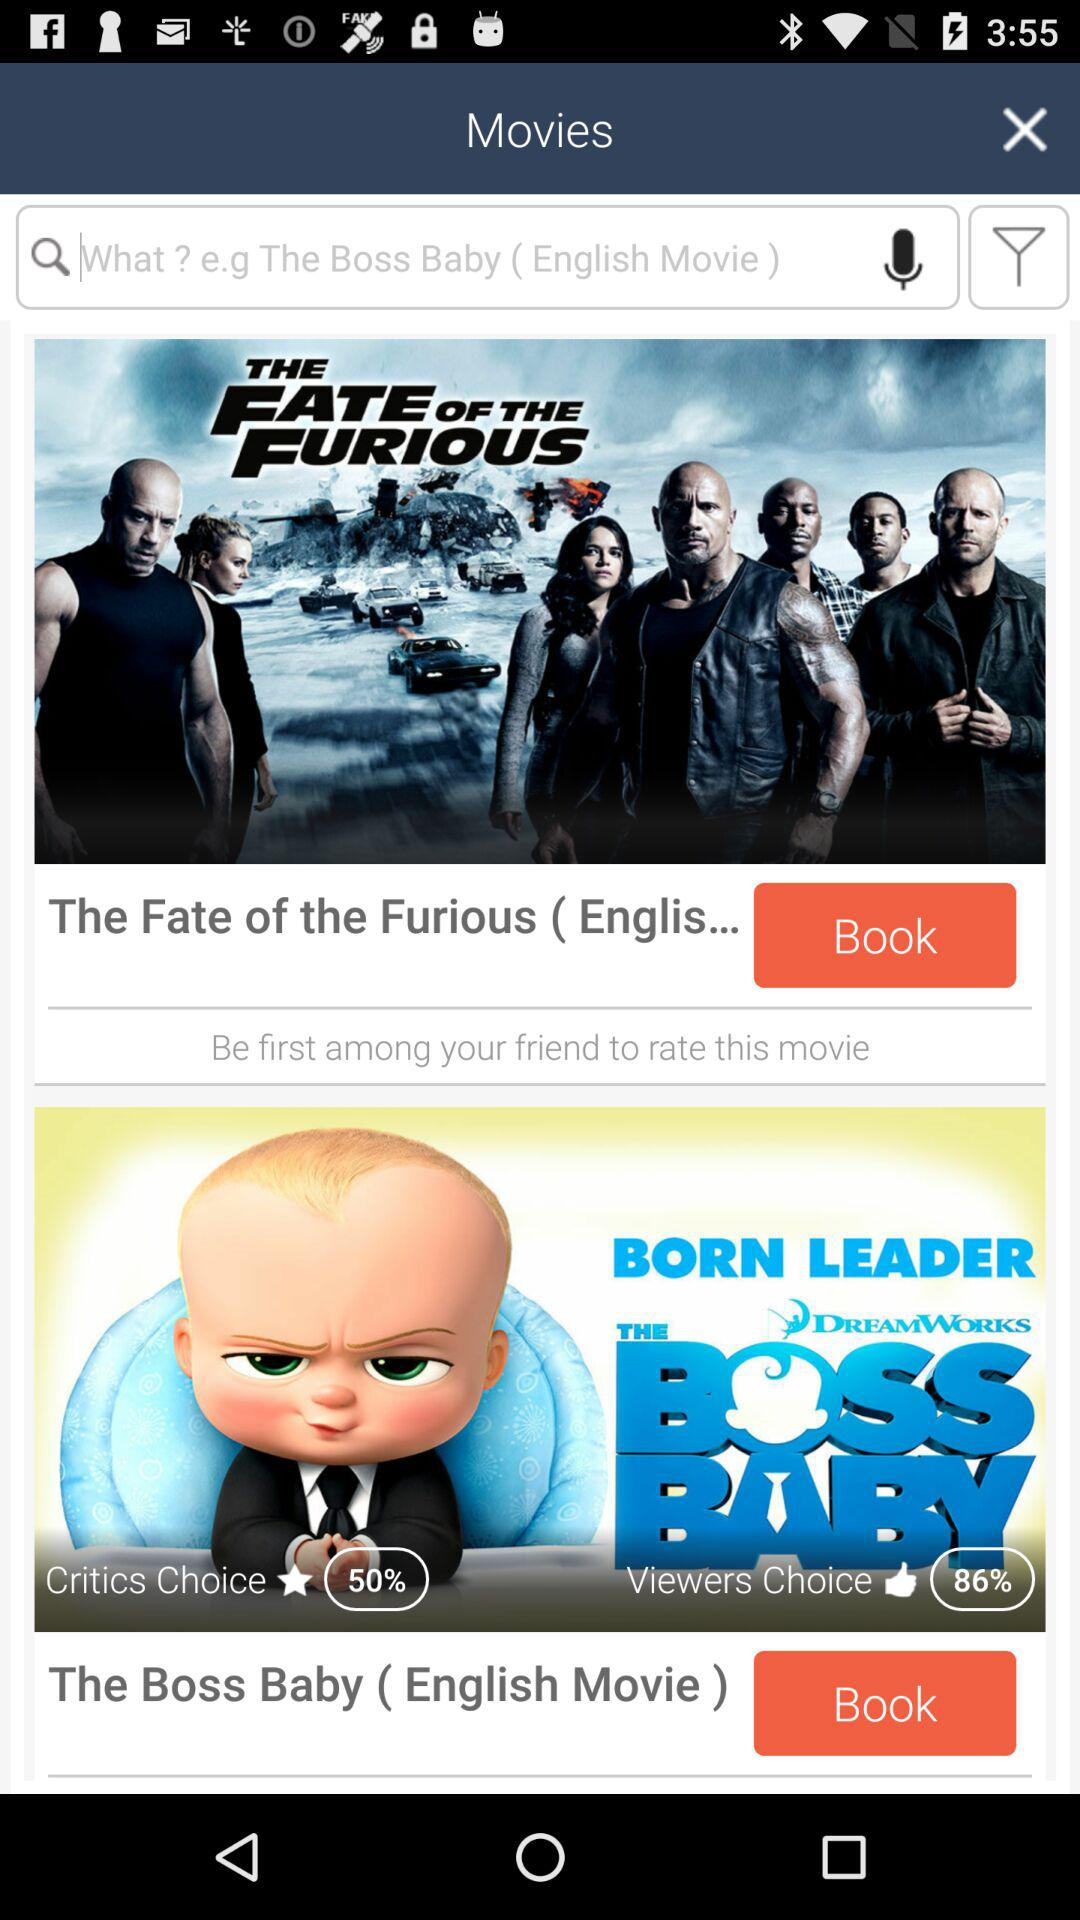What is the percentage of "Viewers Choice" likes? The percentage of "Viewers Choice" likes is 86. 